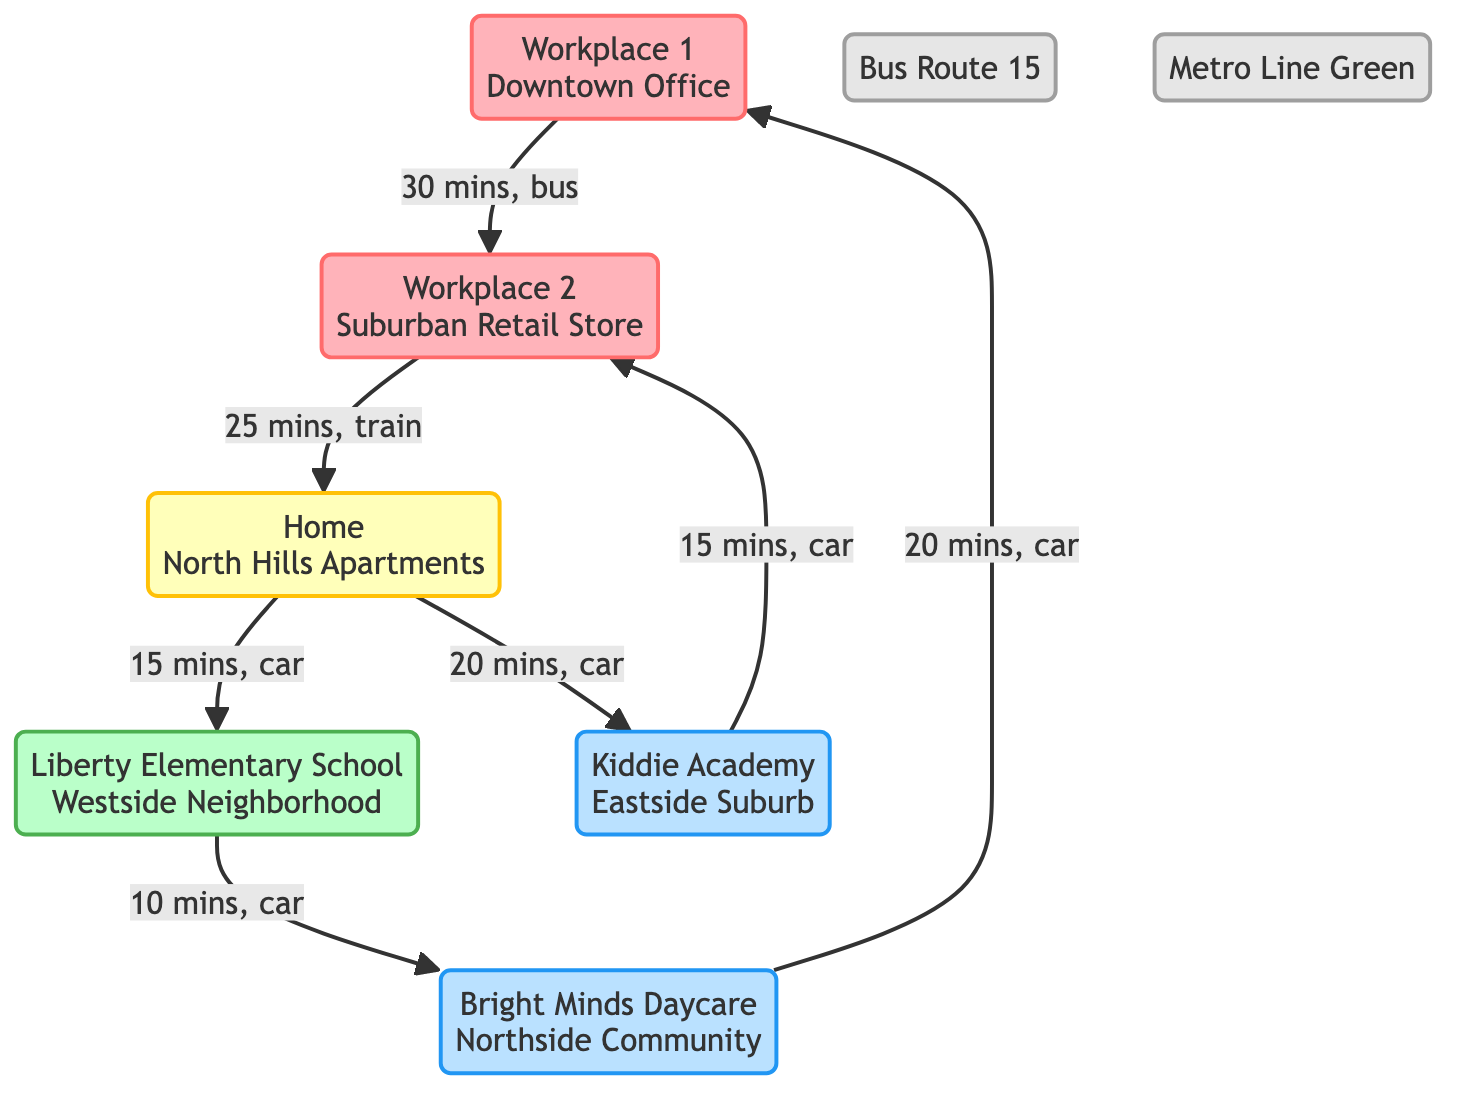What is the duration to commute from Home to Liberty Elementary School? The link between Home and Liberty Elementary School specifies that the duration is 15 mins when traveling by car.
Answer: 15 mins How many childcare centers are shown in the diagram? The diagram includes two childcare centers: Bright Minds Daycare and Kiddie Academy. This makes a total of two childcare centers.
Answer: 2 Which workplace is connected to Liberty Elementary School? The flow shows that Liberty Elementary School is directly connected to Bright Minds Daycare, which in turn connects to Workplace 1. Hence, Workplace 1 is the workplace connected through this route.
Answer: Workplace 1 What is the total commute duration from Home to Workplace 1? Starting from Home to Liberty Elementary School is 15 mins, from there to Bright Minds Daycare is 10 mins, and then from Bright Minds Daycare to Workplace 1 is 20 mins. Adding these durations gives: 15 + 10 + 20 = 45 mins.
Answer: 45 mins Is there a direct connection from Home to any childcare center? The diagram shows a direct connection from Home to Kiddie Academy, with a commute duration of 20 mins.
Answer: Yes What type of transport is used between Workplace 1 and Workplace 2? The link between Workplace 1 and Workplace 2 indicates that the mode of transport is a bus, specifically Bus Route 15.
Answer: Bus Route 15 From Kiddie Academy, how long does it take to get to Workplace 2? The link indicates a commute duration of 15 mins from Kiddie Academy to Workplace 2, which is derived from the connection directly between these two nodes.
Answer: 15 mins What is the mode of transport from Workplace 2 back to Home? The diagram specifies that the mode of transport from Workplace 2 to Home is a train, specifically on the Metro Line Green.
Answer: Metro Line Green 